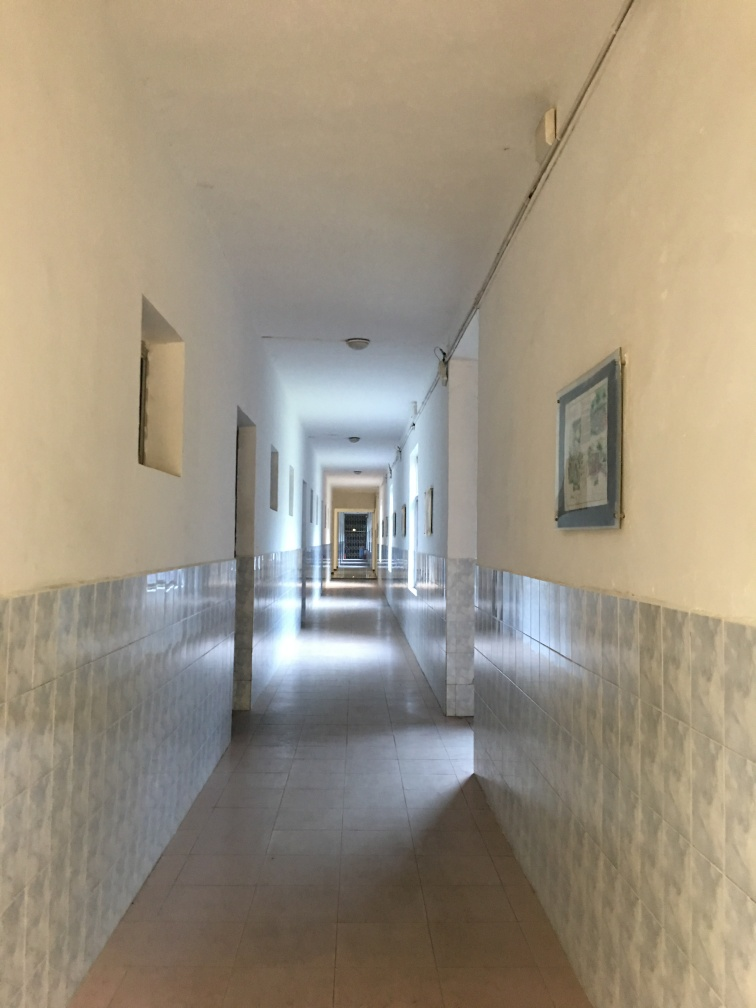What kind of building does this corridor belong to, in your opinion? The corridor might belong to an institutional building such as a school or hospital, inferred from the functional aesthetic, tiled walls, and the orderly arrangement of lights and art. It's designed for heavy foot traffic and practicality, suggesting a public or semi-public space rather than a private residence. 